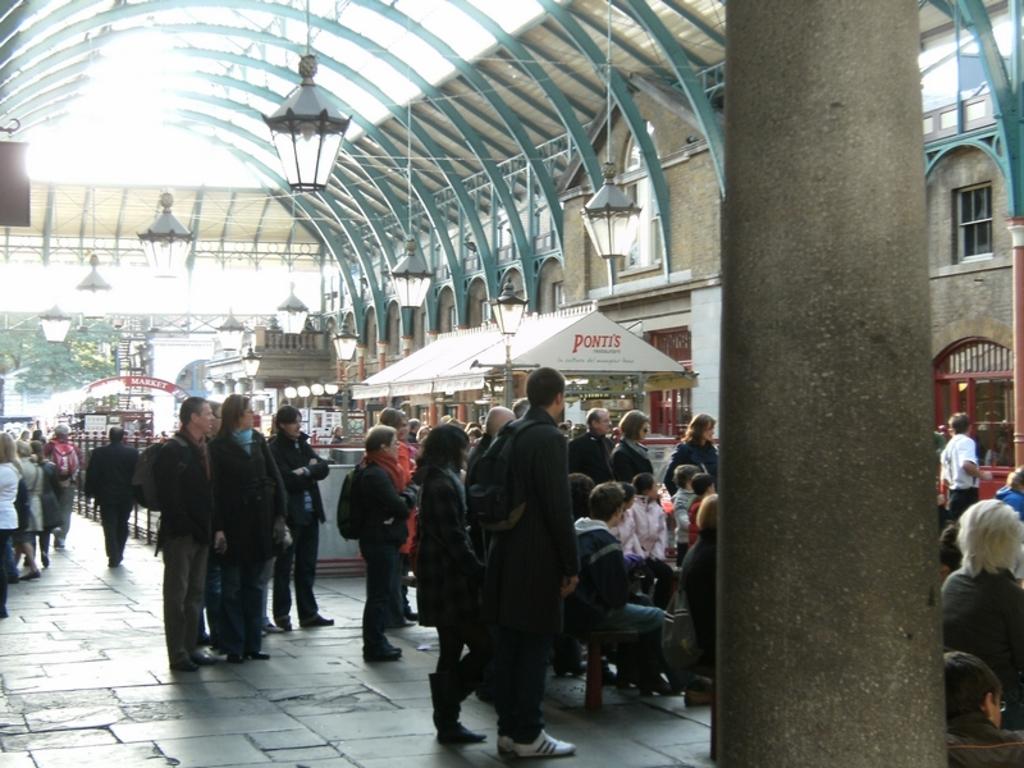What restaurant tent is in the background?
Make the answer very short. Ponti's. What is on the sign in the background describing what the place is?
Ensure brevity in your answer.  Market. 